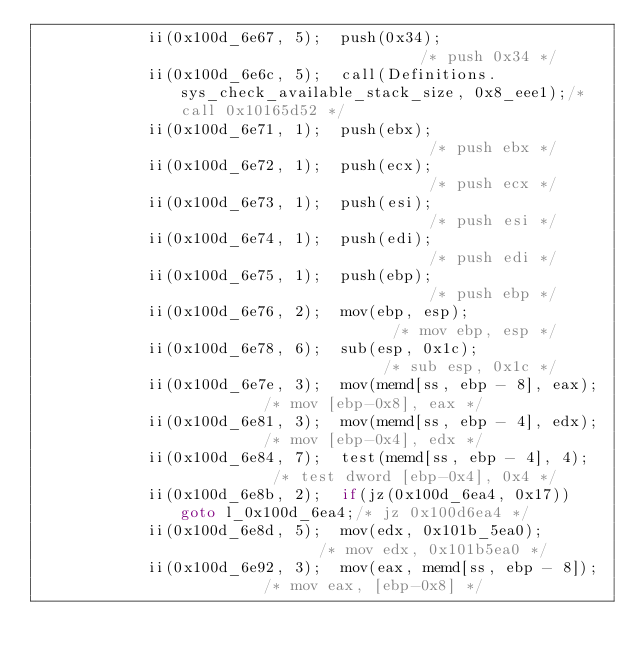<code> <loc_0><loc_0><loc_500><loc_500><_C#_>            ii(0x100d_6e67, 5);  push(0x34);                           /* push 0x34 */
            ii(0x100d_6e6c, 5);  call(Definitions.sys_check_available_stack_size, 0x8_eee1);/* call 0x10165d52 */
            ii(0x100d_6e71, 1);  push(ebx);                            /* push ebx */
            ii(0x100d_6e72, 1);  push(ecx);                            /* push ecx */
            ii(0x100d_6e73, 1);  push(esi);                            /* push esi */
            ii(0x100d_6e74, 1);  push(edi);                            /* push edi */
            ii(0x100d_6e75, 1);  push(ebp);                            /* push ebp */
            ii(0x100d_6e76, 2);  mov(ebp, esp);                        /* mov ebp, esp */
            ii(0x100d_6e78, 6);  sub(esp, 0x1c);                       /* sub esp, 0x1c */
            ii(0x100d_6e7e, 3);  mov(memd[ss, ebp - 8], eax);          /* mov [ebp-0x8], eax */
            ii(0x100d_6e81, 3);  mov(memd[ss, ebp - 4], edx);          /* mov [ebp-0x4], edx */
            ii(0x100d_6e84, 7);  test(memd[ss, ebp - 4], 4);           /* test dword [ebp-0x4], 0x4 */
            ii(0x100d_6e8b, 2);  if(jz(0x100d_6ea4, 0x17)) goto l_0x100d_6ea4;/* jz 0x100d6ea4 */
            ii(0x100d_6e8d, 5);  mov(edx, 0x101b_5ea0);                /* mov edx, 0x101b5ea0 */
            ii(0x100d_6e92, 3);  mov(eax, memd[ss, ebp - 8]);          /* mov eax, [ebp-0x8] */</code> 